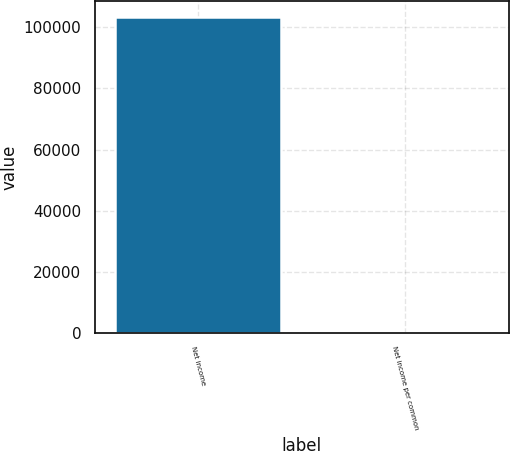Convert chart to OTSL. <chart><loc_0><loc_0><loc_500><loc_500><bar_chart><fcel>Net income<fcel>Net income per common<nl><fcel>103481<fcel>1.55<nl></chart> 